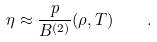<formula> <loc_0><loc_0><loc_500><loc_500>\eta \approx \frac { p } { B ^ { ( 2 ) } } ( \rho , T ) \quad .</formula> 